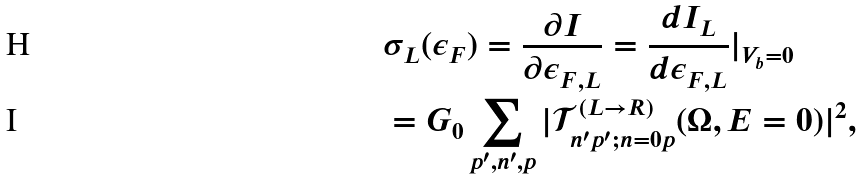Convert formula to latex. <formula><loc_0><loc_0><loc_500><loc_500>& \sigma _ { L } ( \epsilon _ { F } ) = \frac { \partial I } { \partial \epsilon _ { F , L } } = \frac { d I _ { L } } { d \epsilon _ { F , L } } | _ { V _ { b } = 0 } \\ & = G _ { 0 } \sum _ { p ^ { \prime } , n ^ { \prime } , p } | \mathcal { T } _ { n ^ { \prime } p ^ { \prime } ; n = 0 p } ^ { ( L \rightarrow R ) } ( \Omega , E = 0 ) | ^ { 2 } ,</formula> 